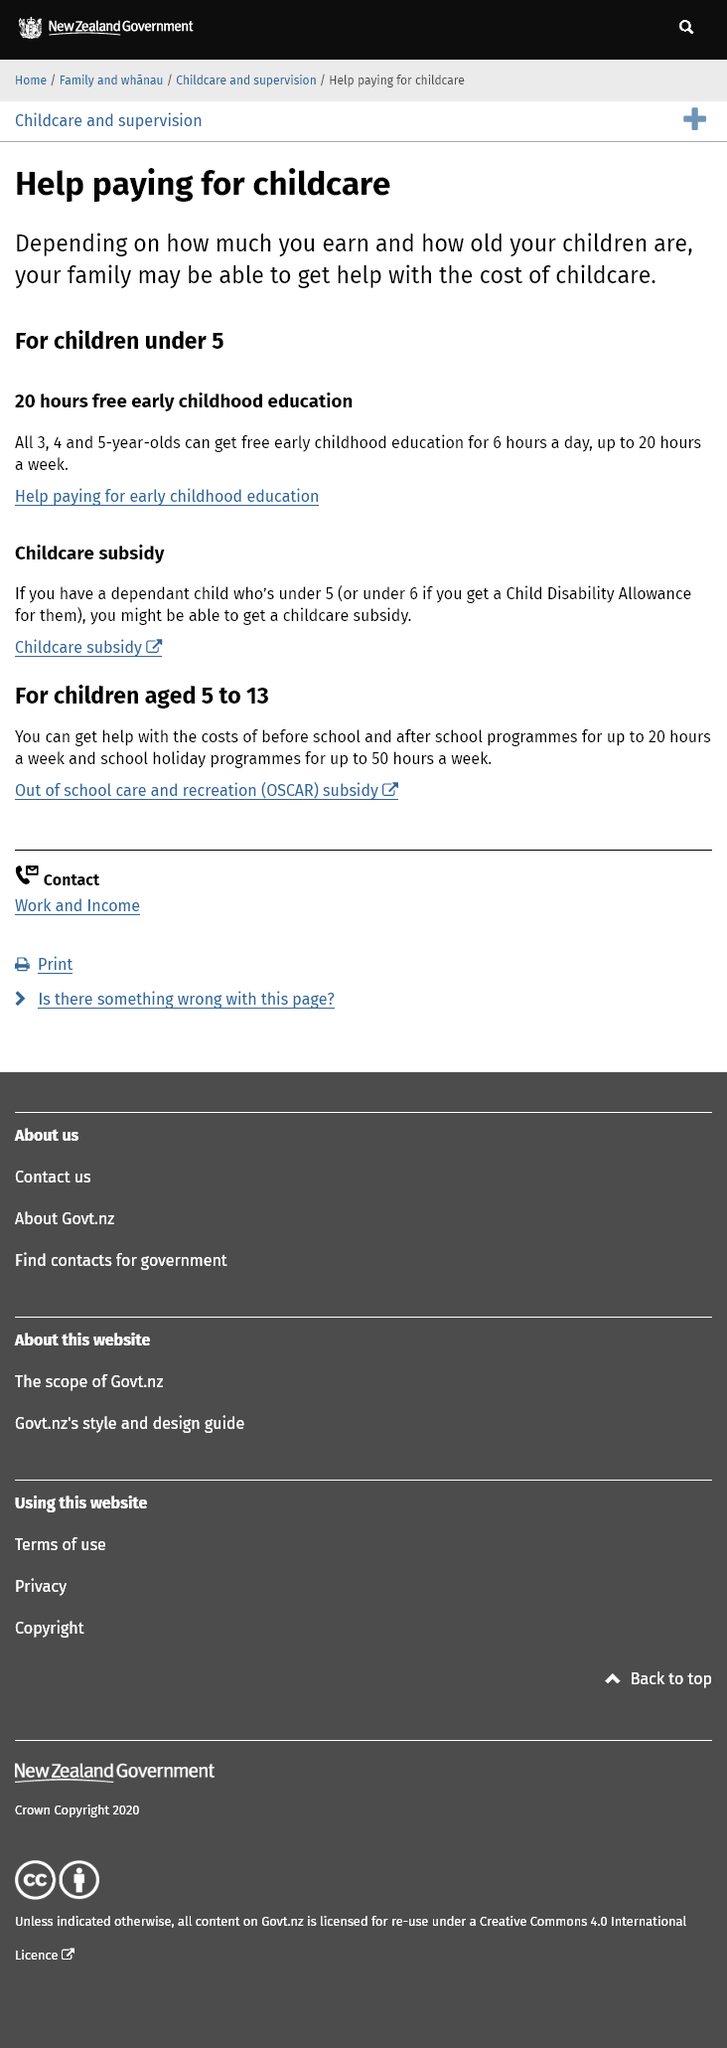Indicate a few pertinent items in this graphic. Under the free early childhood education scheme, twenty hours of education are provided. The free early childhood education scheme includes six hours per day, as stated in the question, 'How many hours per day are included in the free early childhood education scheme?' The free early childhood education scheme is available to children aged 3-5, and they must meet the eligibility criteria to qualify for this benefit. 